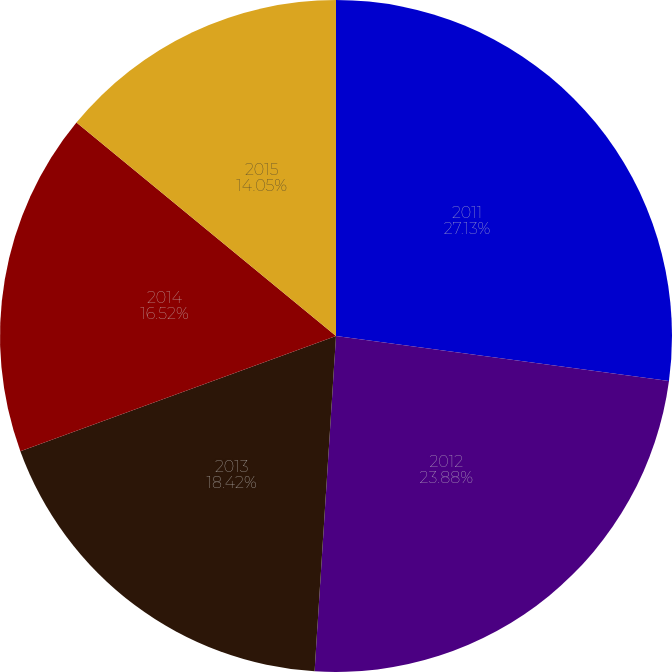<chart> <loc_0><loc_0><loc_500><loc_500><pie_chart><fcel>2011<fcel>2012<fcel>2013<fcel>2014<fcel>2015<nl><fcel>27.14%<fcel>23.88%<fcel>18.42%<fcel>16.52%<fcel>14.05%<nl></chart> 